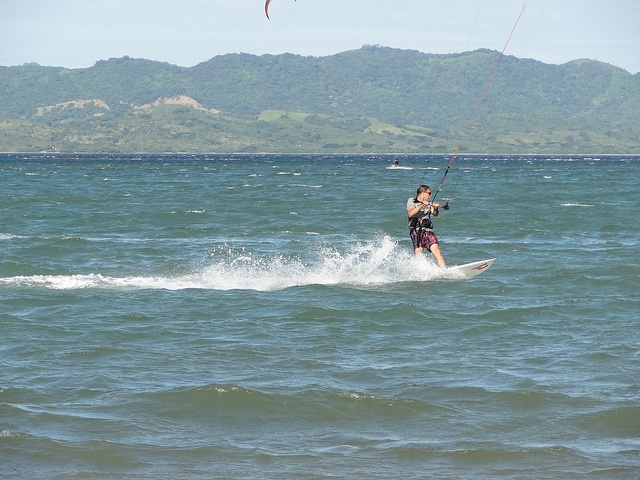Describe the objects in this image and their specific colors. I can see people in lightblue, black, gray, and tan tones and surfboard in lightblue, darkgray, and lightgray tones in this image. 